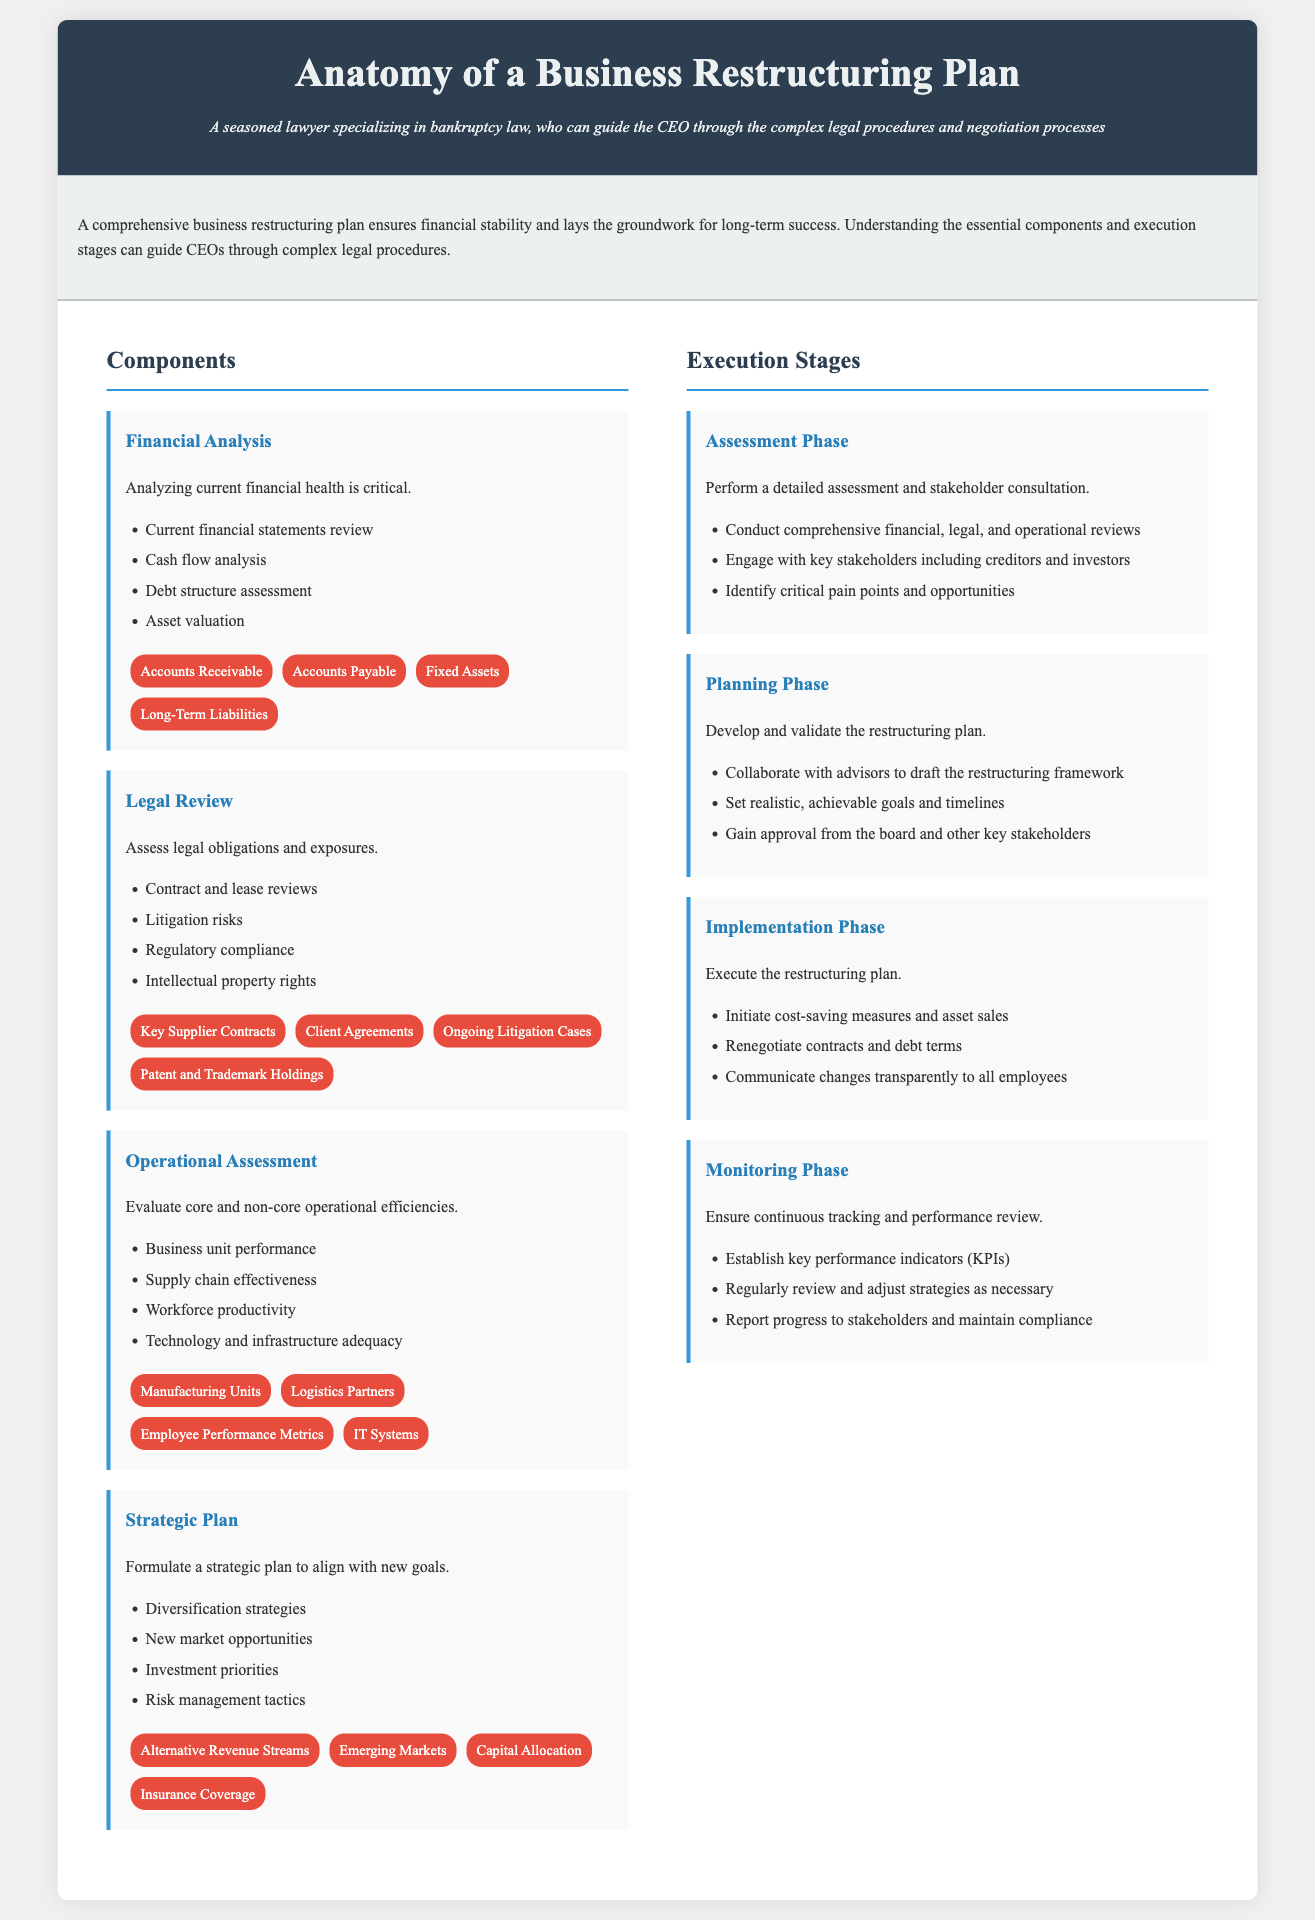What is a critical aspect of financial analysis? The financial analysis must include a review of current financial statements.
Answer: Current financial statements review Which legal obligations are assessed in the legal review? The legal review assesses contract and lease reviews and regulatory compliance among others.
Answer: Contract and lease reviews What phase comes after assessment? The planning phase follows the assessment phase.
Answer: Planning Phase What must be established during the monitoring phase? Key performance indicators (KPIs) must be established during the monitoring phase.
Answer: Key performance indicators (KPIs) Name one of the components of the strategic plan. The strategic plan includes diversification strategies.
Answer: Diversification strategies What type of analysis assesses supply chain effectiveness? The operational assessment evaluates supply chain effectiveness.
Answer: Operational assessment How many execution stages are outlined in the document? There are four execution stages in the document.
Answer: Four What key entity is mentioned in financial analysis? Accounts Receivable is mentioned as a key entity in financial analysis.
Answer: Accounts Receivable What is the purpose of consulting stakeholders in the assessment phase? Consulting stakeholders helps identify critical pain points and opportunities.
Answer: Identify critical pain points and opportunities 